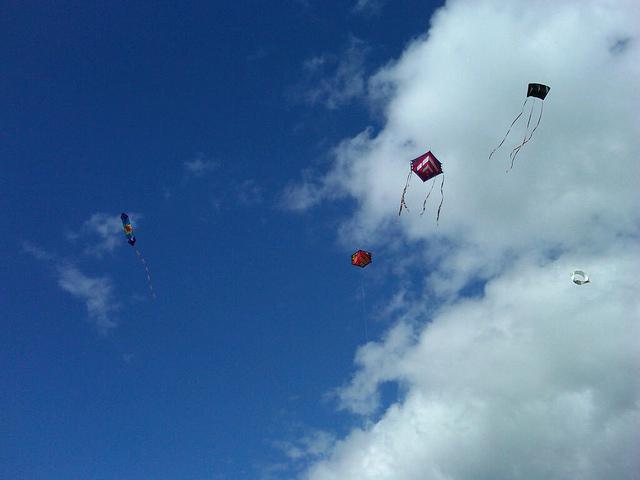Which kite resembles the stripes on the American flag?
Concise answer only. 3rd from left. How long are the kites?
Concise answer only. Long. Is it a windy day?
Keep it brief. Yes. How many kites are in the sky?
Write a very short answer. 5. 